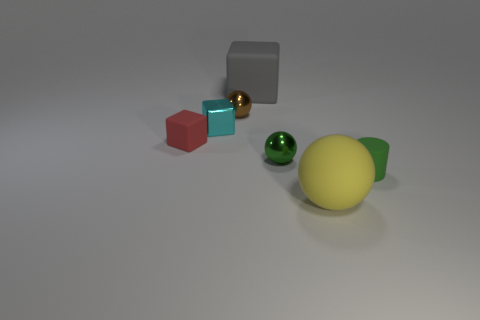Are there any rubber cylinders?
Ensure brevity in your answer.  Yes. There is a ball that is the same color as the cylinder; what is its material?
Give a very brief answer. Metal. How many things are tiny cyan blocks or rubber objects?
Make the answer very short. 5. Are there any other blocks that have the same color as the big rubber block?
Make the answer very short. No. There is a large rubber thing behind the red object; how many yellow matte objects are behind it?
Your answer should be very brief. 0. Is the number of green metallic cubes greater than the number of tiny brown spheres?
Your response must be concise. No. Do the small cylinder and the brown sphere have the same material?
Give a very brief answer. No. Are there an equal number of tiny green balls that are on the right side of the yellow rubber object and rubber cubes?
Provide a short and direct response. No. How many small brown balls have the same material as the large cube?
Your answer should be very brief. 0. Is the number of large gray cubes less than the number of tiny yellow metal spheres?
Your response must be concise. No. 